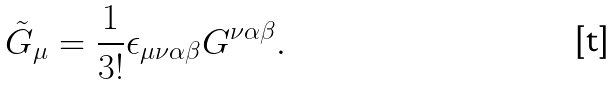<formula> <loc_0><loc_0><loc_500><loc_500>\tilde { G } _ { \mu } = \frac { 1 } { 3 ! } \epsilon _ { \mu \nu \alpha \beta } G ^ { \nu \alpha \beta } .</formula> 